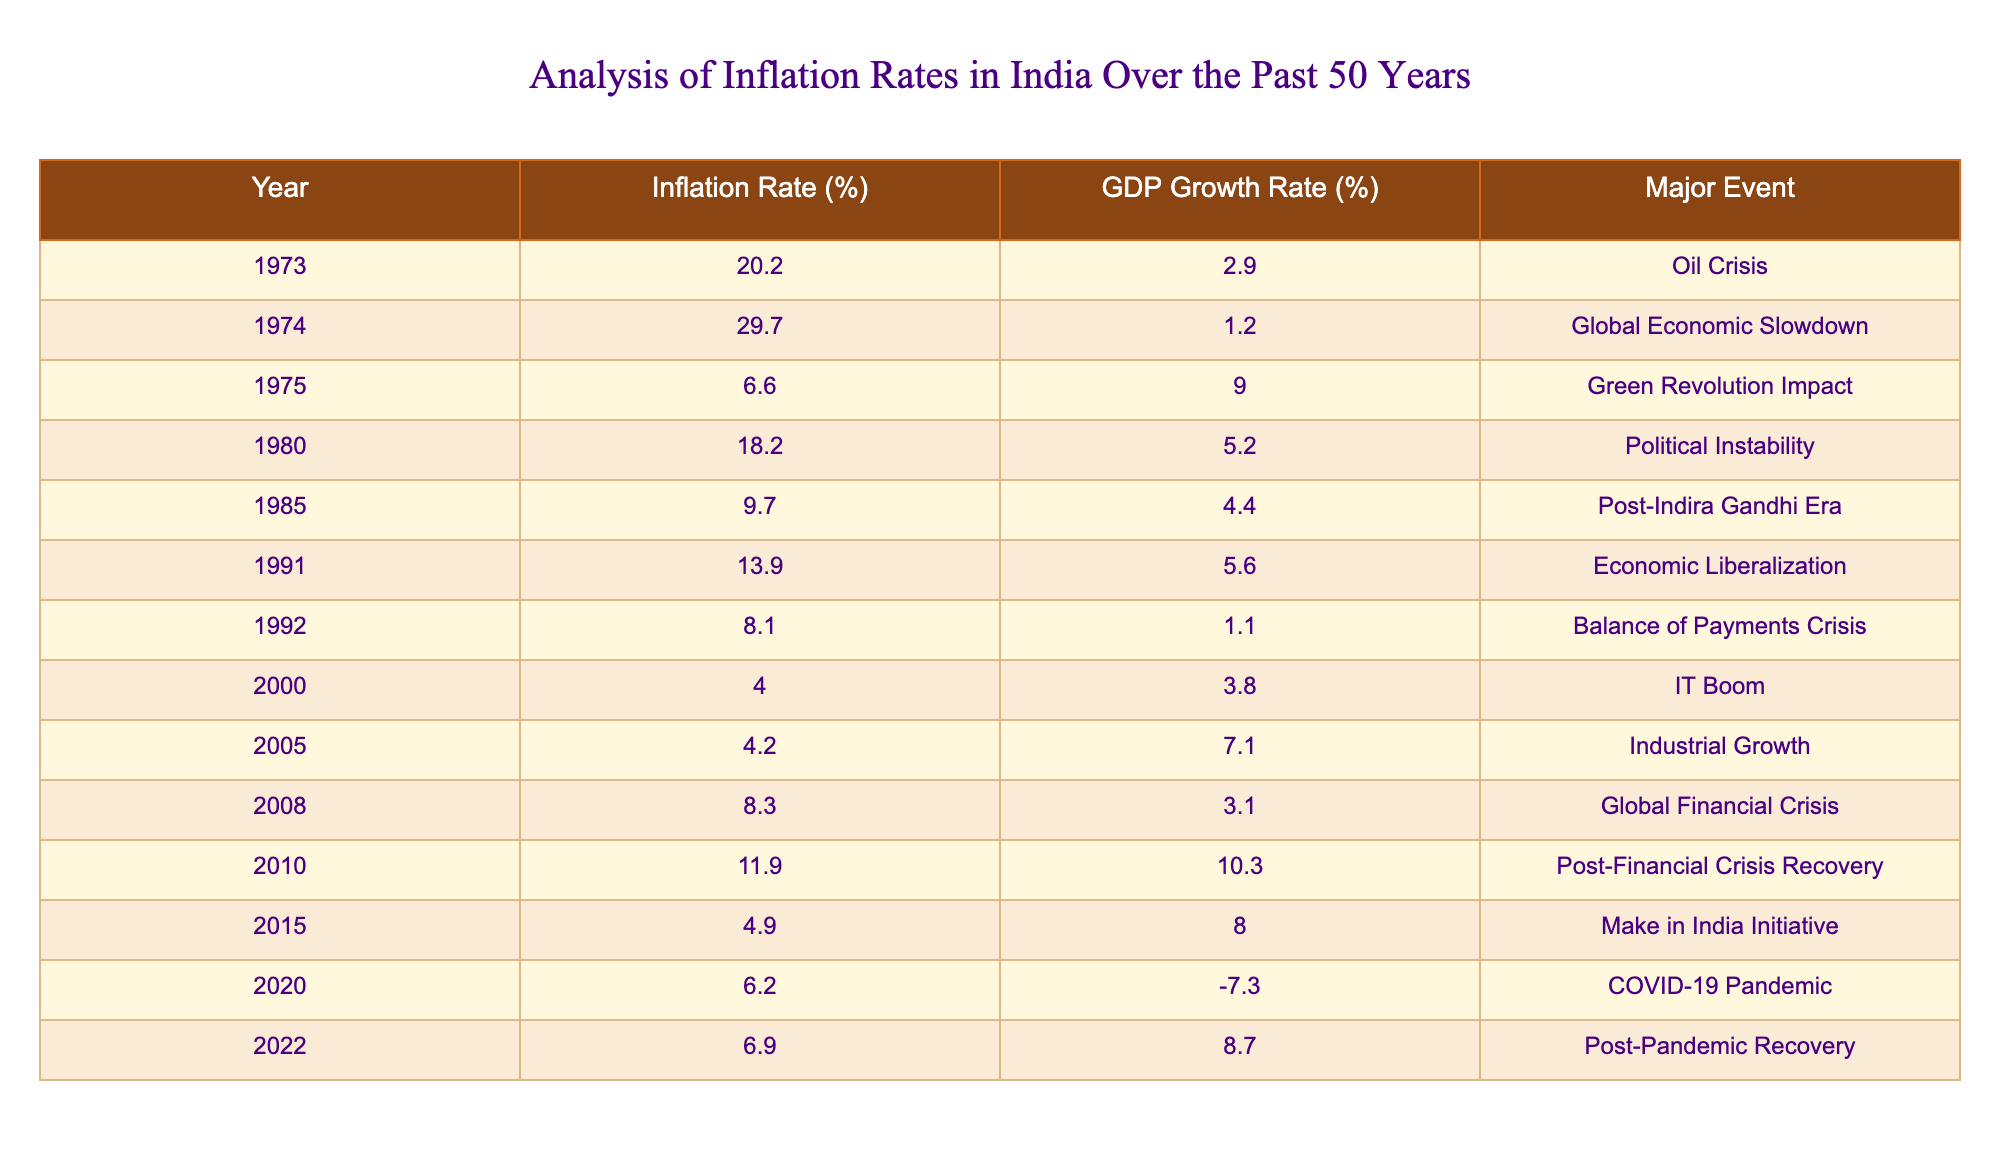What was the highest inflation rate recorded in the table? The table shows that the highest inflation rate recorded was 29.7% in the year 1974. I find this value in the column under 'Inflation Rate (%)' by scanning through the years, and 1974 stands out as the highest.
Answer: 29.7% Which year saw the lowest inflation rate? Upon examining the inflation rates in the table, the lowest inflation rate observed is 4.0% in the year 2000. This can be identified by checking each recorded rate and finding the minimum value.
Answer: 4.0% What was the GDP growth rate in 2020? The table indicates that the GDP growth rate for the year 2020 was -7.3%. This figure is directly retrieved from the 'GDP Growth Rate (%)' column beside the year 2020.
Answer: -7.3% How much did the inflation rate increase from 2005 to 2008? To find the increase in inflation from 2005 to 2008, I subtract the rates: 8.3% (2008) - 4.2% (2005) = 4.1%. This calculation gives the difference in inflation rates between these two years.
Answer: 4.1% Was there a year when the inflation rate and GDP growth rate were both above 10%? By reviewing the table, I see that this statement is false. The only year where inflation was above 10% was 2010 (11.9%) and no corresponding GDP growth rate exceeded 10%. Therefore, this specific condition of both rates being above 10% does not occur in any year.
Answer: No In which year did India experience both a global financial crisis and rising inflation? Looking at the events listed, 2008 corresponds to the global financial crisis, and the inflation rate in that year was 8.3%. Therefore, the year that satisfies both conditions of a financial crisis and an inflation rate above average is indeed 2008.
Answer: 2008 What is the average inflation rate over the entire period listed in the table? To calculate the average inflation rate, I sum all the recorded inflation rates and divide by the number of years (13): (20.2 + 29.7 + 6.6 + 18.2 + 9.7 + 13.9 + 8.1 + 4.0 + 4.2 + 8.3 + 11.9 + 4.9 + 6.2 + 6.9) = 151.4, and then divide that sum by 13, yielding an average of approximately 11.6%.
Answer: 11.6% How many years had an inflation rate below 5%? By counting the years listed, only two years had inflation rates below 5%, specifically 2000 (4.0%) and 2005 (4.2%). Thus, the total count of these years is simply counted straight from the table entries.
Answer: 2 What significant event occurred in 1991 related to the economy? The table states that in 1991, a significant economic event was the Economic Liberalization, which corresponds to the inflation and GDP growth figures provided for that year. This information can be directly found in the 'Major Event' column for 1991.
Answer: Economic Liberalization 